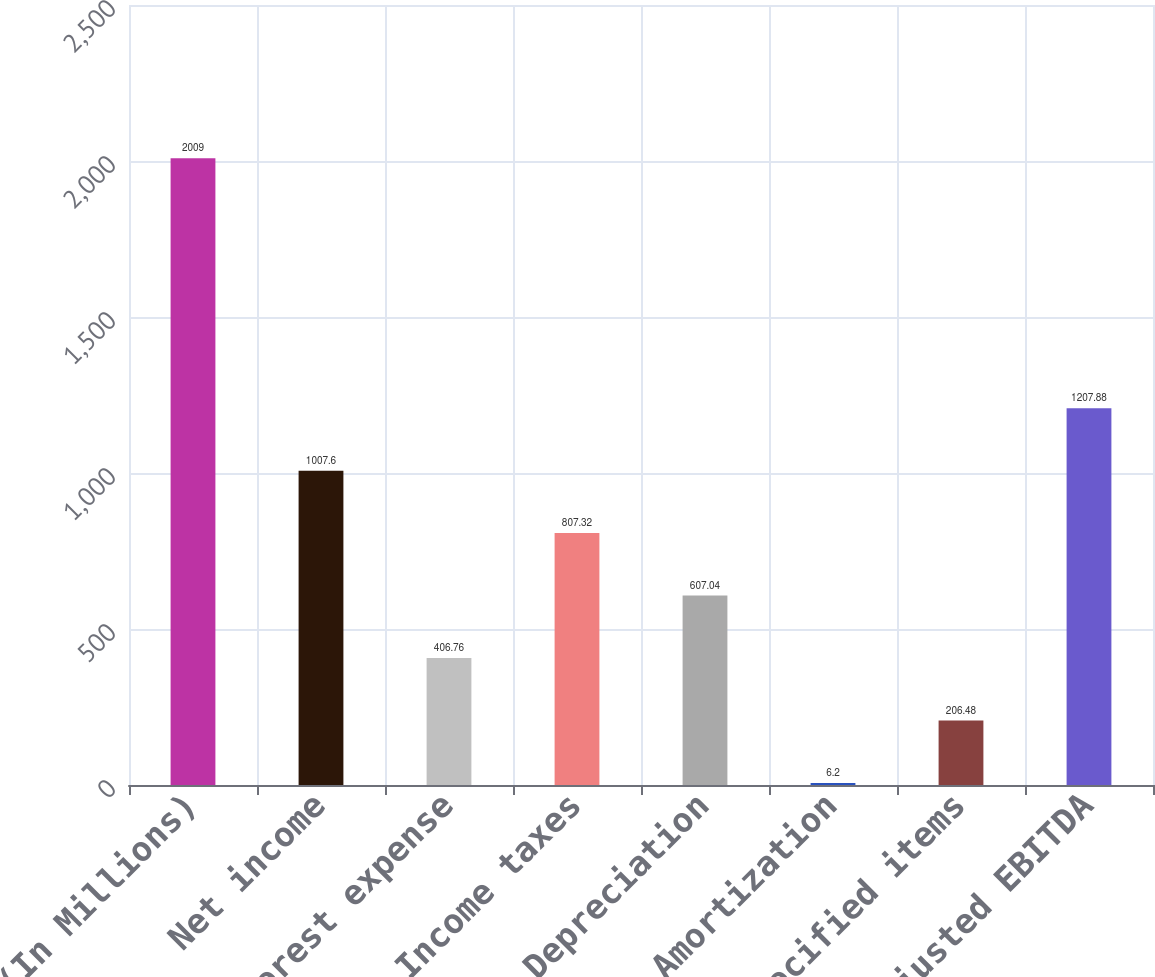<chart> <loc_0><loc_0><loc_500><loc_500><bar_chart><fcel>(In Millions)<fcel>Net income<fcel>Interest expense<fcel>Income taxes<fcel>Depreciation<fcel>Amortization<fcel>Specified items<fcel>Adjusted EBITDA<nl><fcel>2009<fcel>1007.6<fcel>406.76<fcel>807.32<fcel>607.04<fcel>6.2<fcel>206.48<fcel>1207.88<nl></chart> 